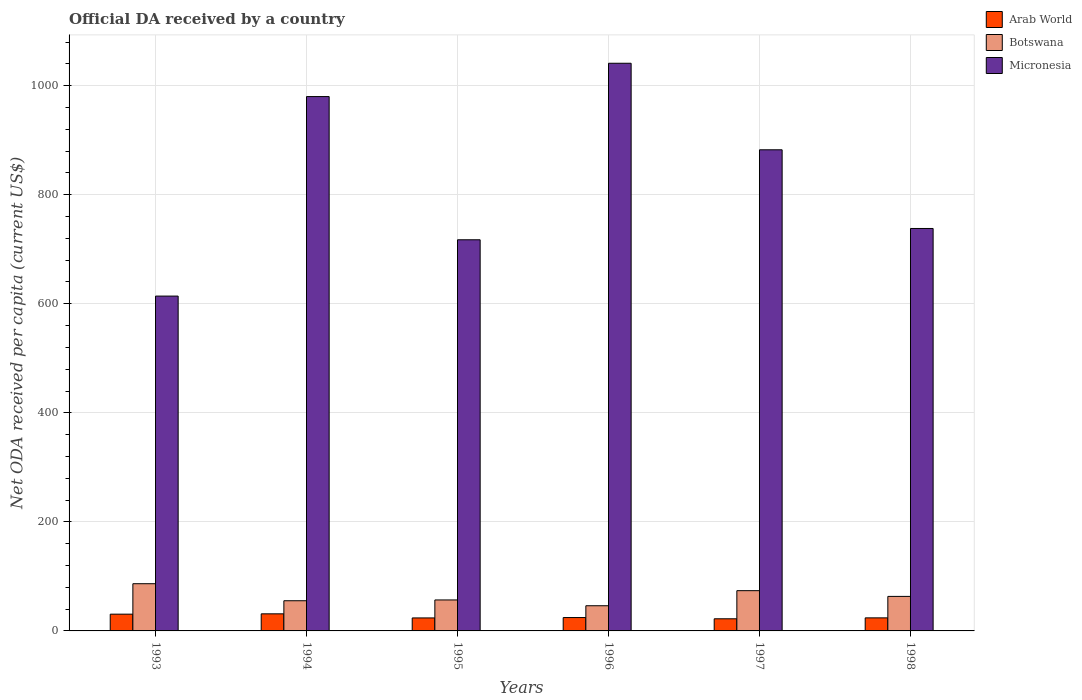How many different coloured bars are there?
Offer a terse response. 3. How many groups of bars are there?
Give a very brief answer. 6. How many bars are there on the 5th tick from the left?
Keep it short and to the point. 3. How many bars are there on the 1st tick from the right?
Your answer should be compact. 3. What is the label of the 5th group of bars from the left?
Offer a very short reply. 1997. In how many cases, is the number of bars for a given year not equal to the number of legend labels?
Your response must be concise. 0. What is the ODA received in in Arab World in 1997?
Your answer should be compact. 22.26. Across all years, what is the maximum ODA received in in Arab World?
Keep it short and to the point. 31.33. Across all years, what is the minimum ODA received in in Botswana?
Your response must be concise. 46.19. What is the total ODA received in in Micronesia in the graph?
Your answer should be compact. 4973.25. What is the difference between the ODA received in in Arab World in 1995 and that in 1997?
Offer a very short reply. 1.57. What is the difference between the ODA received in in Micronesia in 1996 and the ODA received in in Botswana in 1995?
Provide a succinct answer. 984.34. What is the average ODA received in in Arab World per year?
Provide a short and direct response. 26.1. In the year 1998, what is the difference between the ODA received in in Botswana and ODA received in in Arab World?
Ensure brevity in your answer.  39.37. What is the ratio of the ODA received in in Botswana in 1994 to that in 1998?
Your answer should be very brief. 0.87. Is the ODA received in in Arab World in 1996 less than that in 1998?
Offer a terse response. No. Is the difference between the ODA received in in Botswana in 1993 and 1995 greater than the difference between the ODA received in in Arab World in 1993 and 1995?
Keep it short and to the point. Yes. What is the difference between the highest and the second highest ODA received in in Micronesia?
Provide a short and direct response. 61.11. What is the difference between the highest and the lowest ODA received in in Arab World?
Make the answer very short. 9.07. In how many years, is the ODA received in in Botswana greater than the average ODA received in in Botswana taken over all years?
Your answer should be very brief. 2. What does the 1st bar from the left in 1994 represents?
Your answer should be very brief. Arab World. What does the 3rd bar from the right in 1998 represents?
Your response must be concise. Arab World. How many bars are there?
Provide a short and direct response. 18. How many years are there in the graph?
Your response must be concise. 6. Does the graph contain grids?
Ensure brevity in your answer.  Yes. Where does the legend appear in the graph?
Your answer should be very brief. Top right. What is the title of the graph?
Give a very brief answer. Official DA received by a country. Does "Uganda" appear as one of the legend labels in the graph?
Offer a terse response. No. What is the label or title of the Y-axis?
Give a very brief answer. Net ODA received per capita (current US$). What is the Net ODA received per capita (current US$) of Arab World in 1993?
Provide a short and direct response. 30.73. What is the Net ODA received per capita (current US$) in Botswana in 1993?
Provide a succinct answer. 86.58. What is the Net ODA received per capita (current US$) of Micronesia in 1993?
Your answer should be very brief. 614.12. What is the Net ODA received per capita (current US$) of Arab World in 1994?
Your answer should be very brief. 31.33. What is the Net ODA received per capita (current US$) in Botswana in 1994?
Provide a short and direct response. 55.34. What is the Net ODA received per capita (current US$) in Micronesia in 1994?
Give a very brief answer. 980.04. What is the Net ODA received per capita (current US$) in Arab World in 1995?
Make the answer very short. 23.83. What is the Net ODA received per capita (current US$) in Botswana in 1995?
Offer a terse response. 56.8. What is the Net ODA received per capita (current US$) of Micronesia in 1995?
Your response must be concise. 717.39. What is the Net ODA received per capita (current US$) of Arab World in 1996?
Offer a very short reply. 24.52. What is the Net ODA received per capita (current US$) of Botswana in 1996?
Keep it short and to the point. 46.19. What is the Net ODA received per capita (current US$) of Micronesia in 1996?
Offer a terse response. 1041.15. What is the Net ODA received per capita (current US$) of Arab World in 1997?
Keep it short and to the point. 22.26. What is the Net ODA received per capita (current US$) in Botswana in 1997?
Ensure brevity in your answer.  73.82. What is the Net ODA received per capita (current US$) in Micronesia in 1997?
Your response must be concise. 882.44. What is the Net ODA received per capita (current US$) in Arab World in 1998?
Your answer should be very brief. 23.94. What is the Net ODA received per capita (current US$) of Botswana in 1998?
Your answer should be compact. 63.32. What is the Net ODA received per capita (current US$) of Micronesia in 1998?
Ensure brevity in your answer.  738.11. Across all years, what is the maximum Net ODA received per capita (current US$) in Arab World?
Provide a short and direct response. 31.33. Across all years, what is the maximum Net ODA received per capita (current US$) of Botswana?
Provide a short and direct response. 86.58. Across all years, what is the maximum Net ODA received per capita (current US$) of Micronesia?
Ensure brevity in your answer.  1041.15. Across all years, what is the minimum Net ODA received per capita (current US$) of Arab World?
Your answer should be compact. 22.26. Across all years, what is the minimum Net ODA received per capita (current US$) in Botswana?
Your response must be concise. 46.19. Across all years, what is the minimum Net ODA received per capita (current US$) in Micronesia?
Ensure brevity in your answer.  614.12. What is the total Net ODA received per capita (current US$) of Arab World in the graph?
Your response must be concise. 156.61. What is the total Net ODA received per capita (current US$) in Botswana in the graph?
Give a very brief answer. 382.05. What is the total Net ODA received per capita (current US$) in Micronesia in the graph?
Make the answer very short. 4973.25. What is the difference between the Net ODA received per capita (current US$) in Arab World in 1993 and that in 1994?
Give a very brief answer. -0.59. What is the difference between the Net ODA received per capita (current US$) of Botswana in 1993 and that in 1994?
Give a very brief answer. 31.24. What is the difference between the Net ODA received per capita (current US$) in Micronesia in 1993 and that in 1994?
Give a very brief answer. -365.92. What is the difference between the Net ODA received per capita (current US$) of Arab World in 1993 and that in 1995?
Provide a succinct answer. 6.91. What is the difference between the Net ODA received per capita (current US$) in Botswana in 1993 and that in 1995?
Ensure brevity in your answer.  29.78. What is the difference between the Net ODA received per capita (current US$) in Micronesia in 1993 and that in 1995?
Offer a very short reply. -103.27. What is the difference between the Net ODA received per capita (current US$) of Arab World in 1993 and that in 1996?
Provide a short and direct response. 6.22. What is the difference between the Net ODA received per capita (current US$) of Botswana in 1993 and that in 1996?
Your response must be concise. 40.39. What is the difference between the Net ODA received per capita (current US$) of Micronesia in 1993 and that in 1996?
Offer a very short reply. -427.03. What is the difference between the Net ODA received per capita (current US$) of Arab World in 1993 and that in 1997?
Your answer should be compact. 8.47. What is the difference between the Net ODA received per capita (current US$) in Botswana in 1993 and that in 1997?
Give a very brief answer. 12.76. What is the difference between the Net ODA received per capita (current US$) of Micronesia in 1993 and that in 1997?
Give a very brief answer. -268.32. What is the difference between the Net ODA received per capita (current US$) of Arab World in 1993 and that in 1998?
Keep it short and to the point. 6.79. What is the difference between the Net ODA received per capita (current US$) in Botswana in 1993 and that in 1998?
Offer a terse response. 23.26. What is the difference between the Net ODA received per capita (current US$) in Micronesia in 1993 and that in 1998?
Provide a succinct answer. -123.99. What is the difference between the Net ODA received per capita (current US$) in Arab World in 1994 and that in 1995?
Ensure brevity in your answer.  7.5. What is the difference between the Net ODA received per capita (current US$) of Botswana in 1994 and that in 1995?
Your response must be concise. -1.46. What is the difference between the Net ODA received per capita (current US$) of Micronesia in 1994 and that in 1995?
Your answer should be compact. 262.65. What is the difference between the Net ODA received per capita (current US$) of Arab World in 1994 and that in 1996?
Ensure brevity in your answer.  6.81. What is the difference between the Net ODA received per capita (current US$) in Botswana in 1994 and that in 1996?
Provide a succinct answer. 9.15. What is the difference between the Net ODA received per capita (current US$) of Micronesia in 1994 and that in 1996?
Offer a terse response. -61.11. What is the difference between the Net ODA received per capita (current US$) of Arab World in 1994 and that in 1997?
Give a very brief answer. 9.07. What is the difference between the Net ODA received per capita (current US$) in Botswana in 1994 and that in 1997?
Ensure brevity in your answer.  -18.48. What is the difference between the Net ODA received per capita (current US$) in Micronesia in 1994 and that in 1997?
Offer a very short reply. 97.6. What is the difference between the Net ODA received per capita (current US$) in Arab World in 1994 and that in 1998?
Your answer should be compact. 7.38. What is the difference between the Net ODA received per capita (current US$) in Botswana in 1994 and that in 1998?
Provide a short and direct response. -7.97. What is the difference between the Net ODA received per capita (current US$) of Micronesia in 1994 and that in 1998?
Provide a short and direct response. 241.93. What is the difference between the Net ODA received per capita (current US$) in Arab World in 1995 and that in 1996?
Your answer should be compact. -0.69. What is the difference between the Net ODA received per capita (current US$) of Botswana in 1995 and that in 1996?
Give a very brief answer. 10.61. What is the difference between the Net ODA received per capita (current US$) in Micronesia in 1995 and that in 1996?
Your response must be concise. -323.75. What is the difference between the Net ODA received per capita (current US$) in Arab World in 1995 and that in 1997?
Keep it short and to the point. 1.57. What is the difference between the Net ODA received per capita (current US$) in Botswana in 1995 and that in 1997?
Keep it short and to the point. -17.02. What is the difference between the Net ODA received per capita (current US$) in Micronesia in 1995 and that in 1997?
Your response must be concise. -165.05. What is the difference between the Net ODA received per capita (current US$) in Arab World in 1995 and that in 1998?
Ensure brevity in your answer.  -0.11. What is the difference between the Net ODA received per capita (current US$) in Botswana in 1995 and that in 1998?
Offer a terse response. -6.51. What is the difference between the Net ODA received per capita (current US$) in Micronesia in 1995 and that in 1998?
Ensure brevity in your answer.  -20.72. What is the difference between the Net ODA received per capita (current US$) of Arab World in 1996 and that in 1997?
Offer a terse response. 2.26. What is the difference between the Net ODA received per capita (current US$) in Botswana in 1996 and that in 1997?
Make the answer very short. -27.63. What is the difference between the Net ODA received per capita (current US$) of Micronesia in 1996 and that in 1997?
Your answer should be compact. 158.71. What is the difference between the Net ODA received per capita (current US$) in Arab World in 1996 and that in 1998?
Your answer should be very brief. 0.57. What is the difference between the Net ODA received per capita (current US$) of Botswana in 1996 and that in 1998?
Provide a succinct answer. -17.13. What is the difference between the Net ODA received per capita (current US$) of Micronesia in 1996 and that in 1998?
Your answer should be compact. 303.04. What is the difference between the Net ODA received per capita (current US$) of Arab World in 1997 and that in 1998?
Keep it short and to the point. -1.68. What is the difference between the Net ODA received per capita (current US$) of Botswana in 1997 and that in 1998?
Provide a short and direct response. 10.51. What is the difference between the Net ODA received per capita (current US$) in Micronesia in 1997 and that in 1998?
Provide a short and direct response. 144.33. What is the difference between the Net ODA received per capita (current US$) in Arab World in 1993 and the Net ODA received per capita (current US$) in Botswana in 1994?
Provide a short and direct response. -24.61. What is the difference between the Net ODA received per capita (current US$) of Arab World in 1993 and the Net ODA received per capita (current US$) of Micronesia in 1994?
Your response must be concise. -949.3. What is the difference between the Net ODA received per capita (current US$) in Botswana in 1993 and the Net ODA received per capita (current US$) in Micronesia in 1994?
Make the answer very short. -893.46. What is the difference between the Net ODA received per capita (current US$) of Arab World in 1993 and the Net ODA received per capita (current US$) of Botswana in 1995?
Give a very brief answer. -26.07. What is the difference between the Net ODA received per capita (current US$) of Arab World in 1993 and the Net ODA received per capita (current US$) of Micronesia in 1995?
Provide a short and direct response. -686.66. What is the difference between the Net ODA received per capita (current US$) in Botswana in 1993 and the Net ODA received per capita (current US$) in Micronesia in 1995?
Offer a terse response. -630.81. What is the difference between the Net ODA received per capita (current US$) in Arab World in 1993 and the Net ODA received per capita (current US$) in Botswana in 1996?
Your answer should be compact. -15.46. What is the difference between the Net ODA received per capita (current US$) of Arab World in 1993 and the Net ODA received per capita (current US$) of Micronesia in 1996?
Provide a short and direct response. -1010.41. What is the difference between the Net ODA received per capita (current US$) in Botswana in 1993 and the Net ODA received per capita (current US$) in Micronesia in 1996?
Your answer should be very brief. -954.57. What is the difference between the Net ODA received per capita (current US$) of Arab World in 1993 and the Net ODA received per capita (current US$) of Botswana in 1997?
Your answer should be very brief. -43.09. What is the difference between the Net ODA received per capita (current US$) in Arab World in 1993 and the Net ODA received per capita (current US$) in Micronesia in 1997?
Keep it short and to the point. -851.7. What is the difference between the Net ODA received per capita (current US$) in Botswana in 1993 and the Net ODA received per capita (current US$) in Micronesia in 1997?
Make the answer very short. -795.86. What is the difference between the Net ODA received per capita (current US$) in Arab World in 1993 and the Net ODA received per capita (current US$) in Botswana in 1998?
Offer a terse response. -32.58. What is the difference between the Net ODA received per capita (current US$) of Arab World in 1993 and the Net ODA received per capita (current US$) of Micronesia in 1998?
Ensure brevity in your answer.  -707.37. What is the difference between the Net ODA received per capita (current US$) of Botswana in 1993 and the Net ODA received per capita (current US$) of Micronesia in 1998?
Offer a terse response. -651.53. What is the difference between the Net ODA received per capita (current US$) of Arab World in 1994 and the Net ODA received per capita (current US$) of Botswana in 1995?
Give a very brief answer. -25.48. What is the difference between the Net ODA received per capita (current US$) of Arab World in 1994 and the Net ODA received per capita (current US$) of Micronesia in 1995?
Give a very brief answer. -686.07. What is the difference between the Net ODA received per capita (current US$) in Botswana in 1994 and the Net ODA received per capita (current US$) in Micronesia in 1995?
Your response must be concise. -662.05. What is the difference between the Net ODA received per capita (current US$) in Arab World in 1994 and the Net ODA received per capita (current US$) in Botswana in 1996?
Provide a succinct answer. -14.86. What is the difference between the Net ODA received per capita (current US$) of Arab World in 1994 and the Net ODA received per capita (current US$) of Micronesia in 1996?
Provide a short and direct response. -1009.82. What is the difference between the Net ODA received per capita (current US$) of Botswana in 1994 and the Net ODA received per capita (current US$) of Micronesia in 1996?
Make the answer very short. -985.8. What is the difference between the Net ODA received per capita (current US$) of Arab World in 1994 and the Net ODA received per capita (current US$) of Botswana in 1997?
Provide a succinct answer. -42.5. What is the difference between the Net ODA received per capita (current US$) in Arab World in 1994 and the Net ODA received per capita (current US$) in Micronesia in 1997?
Your answer should be compact. -851.11. What is the difference between the Net ODA received per capita (current US$) of Botswana in 1994 and the Net ODA received per capita (current US$) of Micronesia in 1997?
Your response must be concise. -827.1. What is the difference between the Net ODA received per capita (current US$) in Arab World in 1994 and the Net ODA received per capita (current US$) in Botswana in 1998?
Provide a short and direct response. -31.99. What is the difference between the Net ODA received per capita (current US$) of Arab World in 1994 and the Net ODA received per capita (current US$) of Micronesia in 1998?
Your answer should be compact. -706.78. What is the difference between the Net ODA received per capita (current US$) of Botswana in 1994 and the Net ODA received per capita (current US$) of Micronesia in 1998?
Your answer should be compact. -682.77. What is the difference between the Net ODA received per capita (current US$) of Arab World in 1995 and the Net ODA received per capita (current US$) of Botswana in 1996?
Provide a short and direct response. -22.36. What is the difference between the Net ODA received per capita (current US$) in Arab World in 1995 and the Net ODA received per capita (current US$) in Micronesia in 1996?
Offer a terse response. -1017.32. What is the difference between the Net ODA received per capita (current US$) in Botswana in 1995 and the Net ODA received per capita (current US$) in Micronesia in 1996?
Make the answer very short. -984.34. What is the difference between the Net ODA received per capita (current US$) of Arab World in 1995 and the Net ODA received per capita (current US$) of Botswana in 1997?
Make the answer very short. -49.99. What is the difference between the Net ODA received per capita (current US$) in Arab World in 1995 and the Net ODA received per capita (current US$) in Micronesia in 1997?
Your response must be concise. -858.61. What is the difference between the Net ODA received per capita (current US$) of Botswana in 1995 and the Net ODA received per capita (current US$) of Micronesia in 1997?
Provide a short and direct response. -825.64. What is the difference between the Net ODA received per capita (current US$) of Arab World in 1995 and the Net ODA received per capita (current US$) of Botswana in 1998?
Offer a terse response. -39.49. What is the difference between the Net ODA received per capita (current US$) in Arab World in 1995 and the Net ODA received per capita (current US$) in Micronesia in 1998?
Keep it short and to the point. -714.28. What is the difference between the Net ODA received per capita (current US$) of Botswana in 1995 and the Net ODA received per capita (current US$) of Micronesia in 1998?
Offer a terse response. -681.31. What is the difference between the Net ODA received per capita (current US$) of Arab World in 1996 and the Net ODA received per capita (current US$) of Botswana in 1997?
Keep it short and to the point. -49.31. What is the difference between the Net ODA received per capita (current US$) in Arab World in 1996 and the Net ODA received per capita (current US$) in Micronesia in 1997?
Provide a short and direct response. -857.92. What is the difference between the Net ODA received per capita (current US$) in Botswana in 1996 and the Net ODA received per capita (current US$) in Micronesia in 1997?
Your answer should be very brief. -836.25. What is the difference between the Net ODA received per capita (current US$) in Arab World in 1996 and the Net ODA received per capita (current US$) in Botswana in 1998?
Offer a very short reply. -38.8. What is the difference between the Net ODA received per capita (current US$) in Arab World in 1996 and the Net ODA received per capita (current US$) in Micronesia in 1998?
Your response must be concise. -713.59. What is the difference between the Net ODA received per capita (current US$) of Botswana in 1996 and the Net ODA received per capita (current US$) of Micronesia in 1998?
Keep it short and to the point. -691.92. What is the difference between the Net ODA received per capita (current US$) in Arab World in 1997 and the Net ODA received per capita (current US$) in Botswana in 1998?
Provide a succinct answer. -41.06. What is the difference between the Net ODA received per capita (current US$) of Arab World in 1997 and the Net ODA received per capita (current US$) of Micronesia in 1998?
Offer a terse response. -715.85. What is the difference between the Net ODA received per capita (current US$) in Botswana in 1997 and the Net ODA received per capita (current US$) in Micronesia in 1998?
Your response must be concise. -664.29. What is the average Net ODA received per capita (current US$) of Arab World per year?
Your answer should be compact. 26.1. What is the average Net ODA received per capita (current US$) in Botswana per year?
Offer a terse response. 63.68. What is the average Net ODA received per capita (current US$) in Micronesia per year?
Offer a terse response. 828.88. In the year 1993, what is the difference between the Net ODA received per capita (current US$) of Arab World and Net ODA received per capita (current US$) of Botswana?
Provide a short and direct response. -55.84. In the year 1993, what is the difference between the Net ODA received per capita (current US$) of Arab World and Net ODA received per capita (current US$) of Micronesia?
Provide a short and direct response. -583.39. In the year 1993, what is the difference between the Net ODA received per capita (current US$) of Botswana and Net ODA received per capita (current US$) of Micronesia?
Your answer should be very brief. -527.54. In the year 1994, what is the difference between the Net ODA received per capita (current US$) in Arab World and Net ODA received per capita (current US$) in Botswana?
Your answer should be compact. -24.02. In the year 1994, what is the difference between the Net ODA received per capita (current US$) in Arab World and Net ODA received per capita (current US$) in Micronesia?
Provide a succinct answer. -948.71. In the year 1994, what is the difference between the Net ODA received per capita (current US$) in Botswana and Net ODA received per capita (current US$) in Micronesia?
Offer a terse response. -924.7. In the year 1995, what is the difference between the Net ODA received per capita (current US$) of Arab World and Net ODA received per capita (current US$) of Botswana?
Provide a succinct answer. -32.97. In the year 1995, what is the difference between the Net ODA received per capita (current US$) in Arab World and Net ODA received per capita (current US$) in Micronesia?
Your answer should be compact. -693.56. In the year 1995, what is the difference between the Net ODA received per capita (current US$) in Botswana and Net ODA received per capita (current US$) in Micronesia?
Give a very brief answer. -660.59. In the year 1996, what is the difference between the Net ODA received per capita (current US$) in Arab World and Net ODA received per capita (current US$) in Botswana?
Ensure brevity in your answer.  -21.67. In the year 1996, what is the difference between the Net ODA received per capita (current US$) of Arab World and Net ODA received per capita (current US$) of Micronesia?
Ensure brevity in your answer.  -1016.63. In the year 1996, what is the difference between the Net ODA received per capita (current US$) in Botswana and Net ODA received per capita (current US$) in Micronesia?
Your answer should be very brief. -994.96. In the year 1997, what is the difference between the Net ODA received per capita (current US$) in Arab World and Net ODA received per capita (current US$) in Botswana?
Give a very brief answer. -51.56. In the year 1997, what is the difference between the Net ODA received per capita (current US$) of Arab World and Net ODA received per capita (current US$) of Micronesia?
Your answer should be compact. -860.18. In the year 1997, what is the difference between the Net ODA received per capita (current US$) of Botswana and Net ODA received per capita (current US$) of Micronesia?
Provide a succinct answer. -808.62. In the year 1998, what is the difference between the Net ODA received per capita (current US$) of Arab World and Net ODA received per capita (current US$) of Botswana?
Your answer should be very brief. -39.37. In the year 1998, what is the difference between the Net ODA received per capita (current US$) of Arab World and Net ODA received per capita (current US$) of Micronesia?
Your response must be concise. -714.16. In the year 1998, what is the difference between the Net ODA received per capita (current US$) of Botswana and Net ODA received per capita (current US$) of Micronesia?
Give a very brief answer. -674.79. What is the ratio of the Net ODA received per capita (current US$) in Arab World in 1993 to that in 1994?
Your response must be concise. 0.98. What is the ratio of the Net ODA received per capita (current US$) of Botswana in 1993 to that in 1994?
Offer a terse response. 1.56. What is the ratio of the Net ODA received per capita (current US$) in Micronesia in 1993 to that in 1994?
Your response must be concise. 0.63. What is the ratio of the Net ODA received per capita (current US$) of Arab World in 1993 to that in 1995?
Your response must be concise. 1.29. What is the ratio of the Net ODA received per capita (current US$) of Botswana in 1993 to that in 1995?
Give a very brief answer. 1.52. What is the ratio of the Net ODA received per capita (current US$) in Micronesia in 1993 to that in 1995?
Give a very brief answer. 0.86. What is the ratio of the Net ODA received per capita (current US$) in Arab World in 1993 to that in 1996?
Offer a terse response. 1.25. What is the ratio of the Net ODA received per capita (current US$) in Botswana in 1993 to that in 1996?
Keep it short and to the point. 1.87. What is the ratio of the Net ODA received per capita (current US$) of Micronesia in 1993 to that in 1996?
Your response must be concise. 0.59. What is the ratio of the Net ODA received per capita (current US$) in Arab World in 1993 to that in 1997?
Offer a very short reply. 1.38. What is the ratio of the Net ODA received per capita (current US$) in Botswana in 1993 to that in 1997?
Your response must be concise. 1.17. What is the ratio of the Net ODA received per capita (current US$) in Micronesia in 1993 to that in 1997?
Your answer should be very brief. 0.7. What is the ratio of the Net ODA received per capita (current US$) in Arab World in 1993 to that in 1998?
Your response must be concise. 1.28. What is the ratio of the Net ODA received per capita (current US$) of Botswana in 1993 to that in 1998?
Keep it short and to the point. 1.37. What is the ratio of the Net ODA received per capita (current US$) of Micronesia in 1993 to that in 1998?
Ensure brevity in your answer.  0.83. What is the ratio of the Net ODA received per capita (current US$) in Arab World in 1994 to that in 1995?
Offer a terse response. 1.31. What is the ratio of the Net ODA received per capita (current US$) of Botswana in 1994 to that in 1995?
Ensure brevity in your answer.  0.97. What is the ratio of the Net ODA received per capita (current US$) in Micronesia in 1994 to that in 1995?
Provide a short and direct response. 1.37. What is the ratio of the Net ODA received per capita (current US$) of Arab World in 1994 to that in 1996?
Keep it short and to the point. 1.28. What is the ratio of the Net ODA received per capita (current US$) in Botswana in 1994 to that in 1996?
Provide a succinct answer. 1.2. What is the ratio of the Net ODA received per capita (current US$) in Micronesia in 1994 to that in 1996?
Your response must be concise. 0.94. What is the ratio of the Net ODA received per capita (current US$) in Arab World in 1994 to that in 1997?
Provide a short and direct response. 1.41. What is the ratio of the Net ODA received per capita (current US$) of Botswana in 1994 to that in 1997?
Make the answer very short. 0.75. What is the ratio of the Net ODA received per capita (current US$) in Micronesia in 1994 to that in 1997?
Offer a very short reply. 1.11. What is the ratio of the Net ODA received per capita (current US$) of Arab World in 1994 to that in 1998?
Provide a succinct answer. 1.31. What is the ratio of the Net ODA received per capita (current US$) in Botswana in 1994 to that in 1998?
Give a very brief answer. 0.87. What is the ratio of the Net ODA received per capita (current US$) in Micronesia in 1994 to that in 1998?
Offer a very short reply. 1.33. What is the ratio of the Net ODA received per capita (current US$) of Botswana in 1995 to that in 1996?
Provide a succinct answer. 1.23. What is the ratio of the Net ODA received per capita (current US$) in Micronesia in 1995 to that in 1996?
Keep it short and to the point. 0.69. What is the ratio of the Net ODA received per capita (current US$) in Arab World in 1995 to that in 1997?
Your response must be concise. 1.07. What is the ratio of the Net ODA received per capita (current US$) in Botswana in 1995 to that in 1997?
Your response must be concise. 0.77. What is the ratio of the Net ODA received per capita (current US$) in Micronesia in 1995 to that in 1997?
Ensure brevity in your answer.  0.81. What is the ratio of the Net ODA received per capita (current US$) of Arab World in 1995 to that in 1998?
Offer a very short reply. 1. What is the ratio of the Net ODA received per capita (current US$) in Botswana in 1995 to that in 1998?
Ensure brevity in your answer.  0.9. What is the ratio of the Net ODA received per capita (current US$) of Micronesia in 1995 to that in 1998?
Make the answer very short. 0.97. What is the ratio of the Net ODA received per capita (current US$) in Arab World in 1996 to that in 1997?
Offer a terse response. 1.1. What is the ratio of the Net ODA received per capita (current US$) of Botswana in 1996 to that in 1997?
Provide a short and direct response. 0.63. What is the ratio of the Net ODA received per capita (current US$) in Micronesia in 1996 to that in 1997?
Your answer should be very brief. 1.18. What is the ratio of the Net ODA received per capita (current US$) of Arab World in 1996 to that in 1998?
Provide a succinct answer. 1.02. What is the ratio of the Net ODA received per capita (current US$) in Botswana in 1996 to that in 1998?
Give a very brief answer. 0.73. What is the ratio of the Net ODA received per capita (current US$) in Micronesia in 1996 to that in 1998?
Your answer should be compact. 1.41. What is the ratio of the Net ODA received per capita (current US$) of Arab World in 1997 to that in 1998?
Make the answer very short. 0.93. What is the ratio of the Net ODA received per capita (current US$) of Botswana in 1997 to that in 1998?
Provide a succinct answer. 1.17. What is the ratio of the Net ODA received per capita (current US$) in Micronesia in 1997 to that in 1998?
Give a very brief answer. 1.2. What is the difference between the highest and the second highest Net ODA received per capita (current US$) of Arab World?
Keep it short and to the point. 0.59. What is the difference between the highest and the second highest Net ODA received per capita (current US$) of Botswana?
Make the answer very short. 12.76. What is the difference between the highest and the second highest Net ODA received per capita (current US$) of Micronesia?
Ensure brevity in your answer.  61.11. What is the difference between the highest and the lowest Net ODA received per capita (current US$) in Arab World?
Your response must be concise. 9.07. What is the difference between the highest and the lowest Net ODA received per capita (current US$) of Botswana?
Provide a succinct answer. 40.39. What is the difference between the highest and the lowest Net ODA received per capita (current US$) in Micronesia?
Make the answer very short. 427.03. 